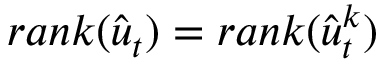Convert formula to latex. <formula><loc_0><loc_0><loc_500><loc_500>r a n k ( \hat { u } _ { t } ) = r a n k ( \hat { u } _ { t } ^ { k } )</formula> 